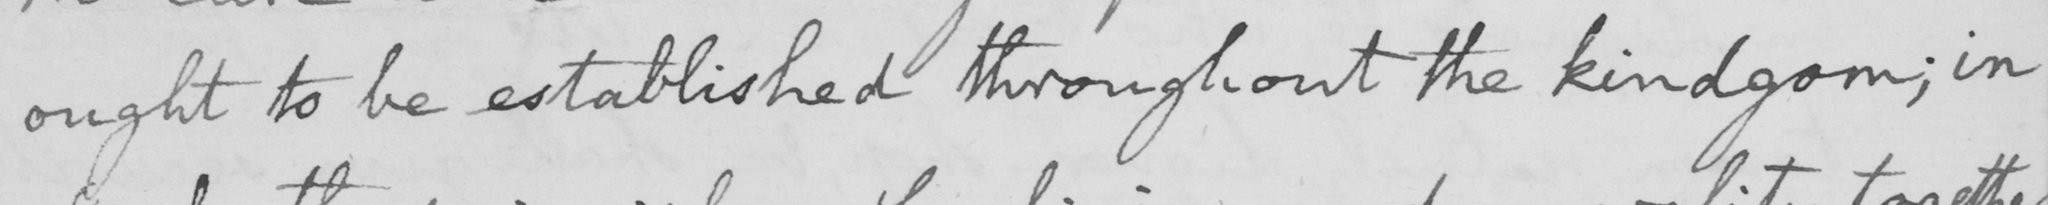What does this handwritten line say? ought to be established throughout the kindgom  ; in 